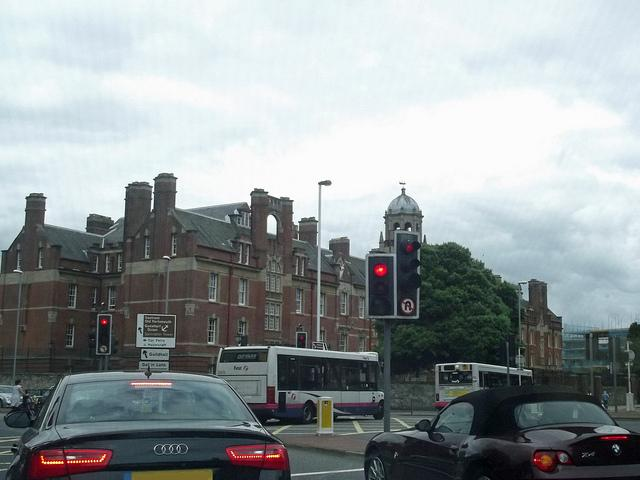What country are these cars manufactured in?

Choices:
A) poland
B) japan
C) usa
D) germany germany 